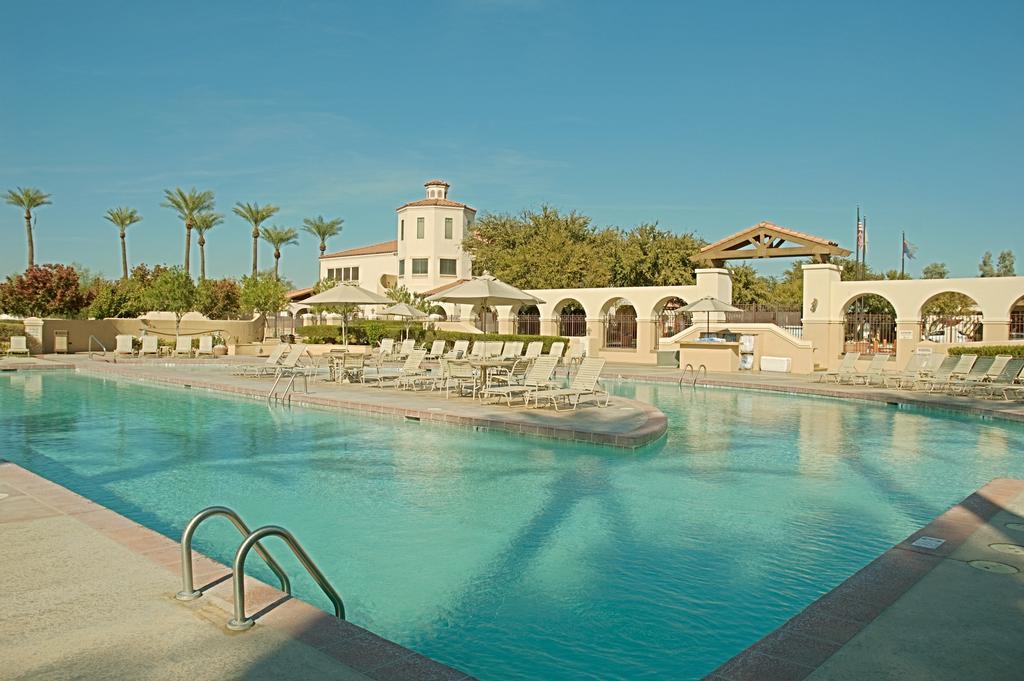Describe this image in one or two sentences. It looks like a resort and there is a big swimming pool and behind the swimming pool there is a building inside the resort and there are plenty of trees around the resort. 